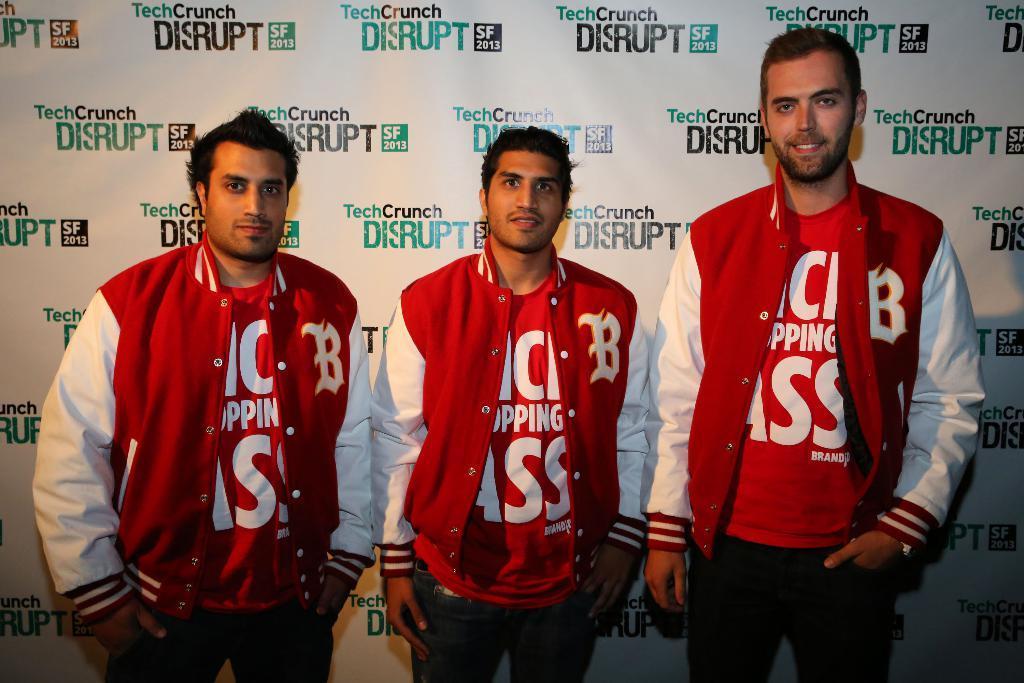Describe this image in one or two sentences. Here I can see three men wearing same dresses, standing, smiling and giving pose for the picture. In the background there is a board on which I can see the text. 